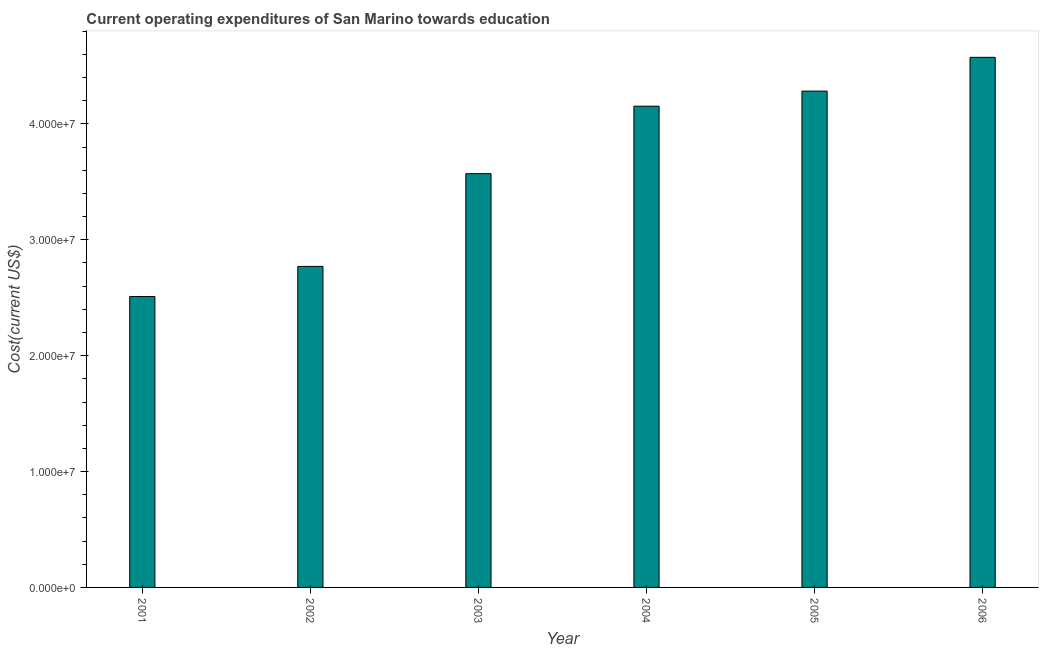Does the graph contain grids?
Ensure brevity in your answer.  No. What is the title of the graph?
Provide a succinct answer. Current operating expenditures of San Marino towards education. What is the label or title of the Y-axis?
Give a very brief answer. Cost(current US$). What is the education expenditure in 2001?
Provide a succinct answer. 2.51e+07. Across all years, what is the maximum education expenditure?
Provide a short and direct response. 4.57e+07. Across all years, what is the minimum education expenditure?
Your response must be concise. 2.51e+07. In which year was the education expenditure minimum?
Provide a short and direct response. 2001. What is the sum of the education expenditure?
Provide a succinct answer. 2.19e+08. What is the difference between the education expenditure in 2003 and 2004?
Your response must be concise. -5.82e+06. What is the average education expenditure per year?
Your answer should be very brief. 3.64e+07. What is the median education expenditure?
Provide a short and direct response. 3.86e+07. In how many years, is the education expenditure greater than 10000000 US$?
Give a very brief answer. 6. Do a majority of the years between 2003 and 2006 (inclusive) have education expenditure greater than 10000000 US$?
Offer a terse response. Yes. What is the ratio of the education expenditure in 2003 to that in 2006?
Keep it short and to the point. 0.78. Is the education expenditure in 2001 less than that in 2005?
Provide a short and direct response. Yes. What is the difference between the highest and the second highest education expenditure?
Keep it short and to the point. 2.91e+06. Is the sum of the education expenditure in 2002 and 2005 greater than the maximum education expenditure across all years?
Ensure brevity in your answer.  Yes. What is the difference between the highest and the lowest education expenditure?
Your response must be concise. 2.06e+07. In how many years, is the education expenditure greater than the average education expenditure taken over all years?
Give a very brief answer. 3. What is the difference between two consecutive major ticks on the Y-axis?
Your answer should be very brief. 1.00e+07. Are the values on the major ticks of Y-axis written in scientific E-notation?
Your answer should be very brief. Yes. What is the Cost(current US$) of 2001?
Keep it short and to the point. 2.51e+07. What is the Cost(current US$) of 2002?
Keep it short and to the point. 2.77e+07. What is the Cost(current US$) of 2003?
Your answer should be very brief. 3.57e+07. What is the Cost(current US$) in 2004?
Provide a succinct answer. 4.15e+07. What is the Cost(current US$) of 2005?
Ensure brevity in your answer.  4.28e+07. What is the Cost(current US$) in 2006?
Ensure brevity in your answer.  4.57e+07. What is the difference between the Cost(current US$) in 2001 and 2002?
Your answer should be compact. -2.60e+06. What is the difference between the Cost(current US$) in 2001 and 2003?
Your answer should be compact. -1.06e+07. What is the difference between the Cost(current US$) in 2001 and 2004?
Your response must be concise. -1.64e+07. What is the difference between the Cost(current US$) in 2001 and 2005?
Your answer should be compact. -1.77e+07. What is the difference between the Cost(current US$) in 2001 and 2006?
Your answer should be compact. -2.06e+07. What is the difference between the Cost(current US$) in 2002 and 2003?
Your response must be concise. -8.00e+06. What is the difference between the Cost(current US$) in 2002 and 2004?
Provide a short and direct response. -1.38e+07. What is the difference between the Cost(current US$) in 2002 and 2005?
Your response must be concise. -1.51e+07. What is the difference between the Cost(current US$) in 2002 and 2006?
Keep it short and to the point. -1.80e+07. What is the difference between the Cost(current US$) in 2003 and 2004?
Ensure brevity in your answer.  -5.82e+06. What is the difference between the Cost(current US$) in 2003 and 2005?
Make the answer very short. -7.13e+06. What is the difference between the Cost(current US$) in 2003 and 2006?
Make the answer very short. -1.00e+07. What is the difference between the Cost(current US$) in 2004 and 2005?
Offer a terse response. -1.30e+06. What is the difference between the Cost(current US$) in 2004 and 2006?
Your answer should be very brief. -4.22e+06. What is the difference between the Cost(current US$) in 2005 and 2006?
Your answer should be compact. -2.91e+06. What is the ratio of the Cost(current US$) in 2001 to that in 2002?
Offer a terse response. 0.91. What is the ratio of the Cost(current US$) in 2001 to that in 2003?
Your answer should be compact. 0.7. What is the ratio of the Cost(current US$) in 2001 to that in 2004?
Provide a succinct answer. 0.6. What is the ratio of the Cost(current US$) in 2001 to that in 2005?
Keep it short and to the point. 0.59. What is the ratio of the Cost(current US$) in 2001 to that in 2006?
Your answer should be very brief. 0.55. What is the ratio of the Cost(current US$) in 2002 to that in 2003?
Offer a very short reply. 0.78. What is the ratio of the Cost(current US$) in 2002 to that in 2004?
Give a very brief answer. 0.67. What is the ratio of the Cost(current US$) in 2002 to that in 2005?
Your answer should be very brief. 0.65. What is the ratio of the Cost(current US$) in 2002 to that in 2006?
Keep it short and to the point. 0.61. What is the ratio of the Cost(current US$) in 2003 to that in 2004?
Offer a very short reply. 0.86. What is the ratio of the Cost(current US$) in 2003 to that in 2005?
Offer a terse response. 0.83. What is the ratio of the Cost(current US$) in 2003 to that in 2006?
Ensure brevity in your answer.  0.78. What is the ratio of the Cost(current US$) in 2004 to that in 2005?
Your answer should be compact. 0.97. What is the ratio of the Cost(current US$) in 2004 to that in 2006?
Make the answer very short. 0.91. What is the ratio of the Cost(current US$) in 2005 to that in 2006?
Keep it short and to the point. 0.94. 